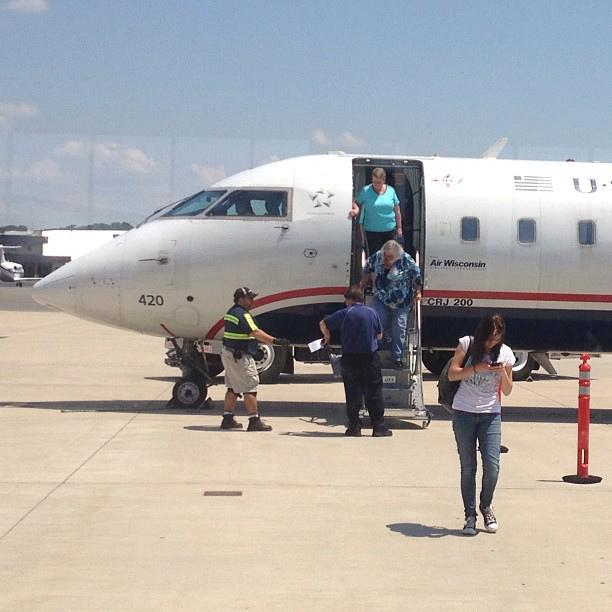What is the woman in the white shirt using in her hands? Please explain your reasoning. phone. The woman has a phone. 